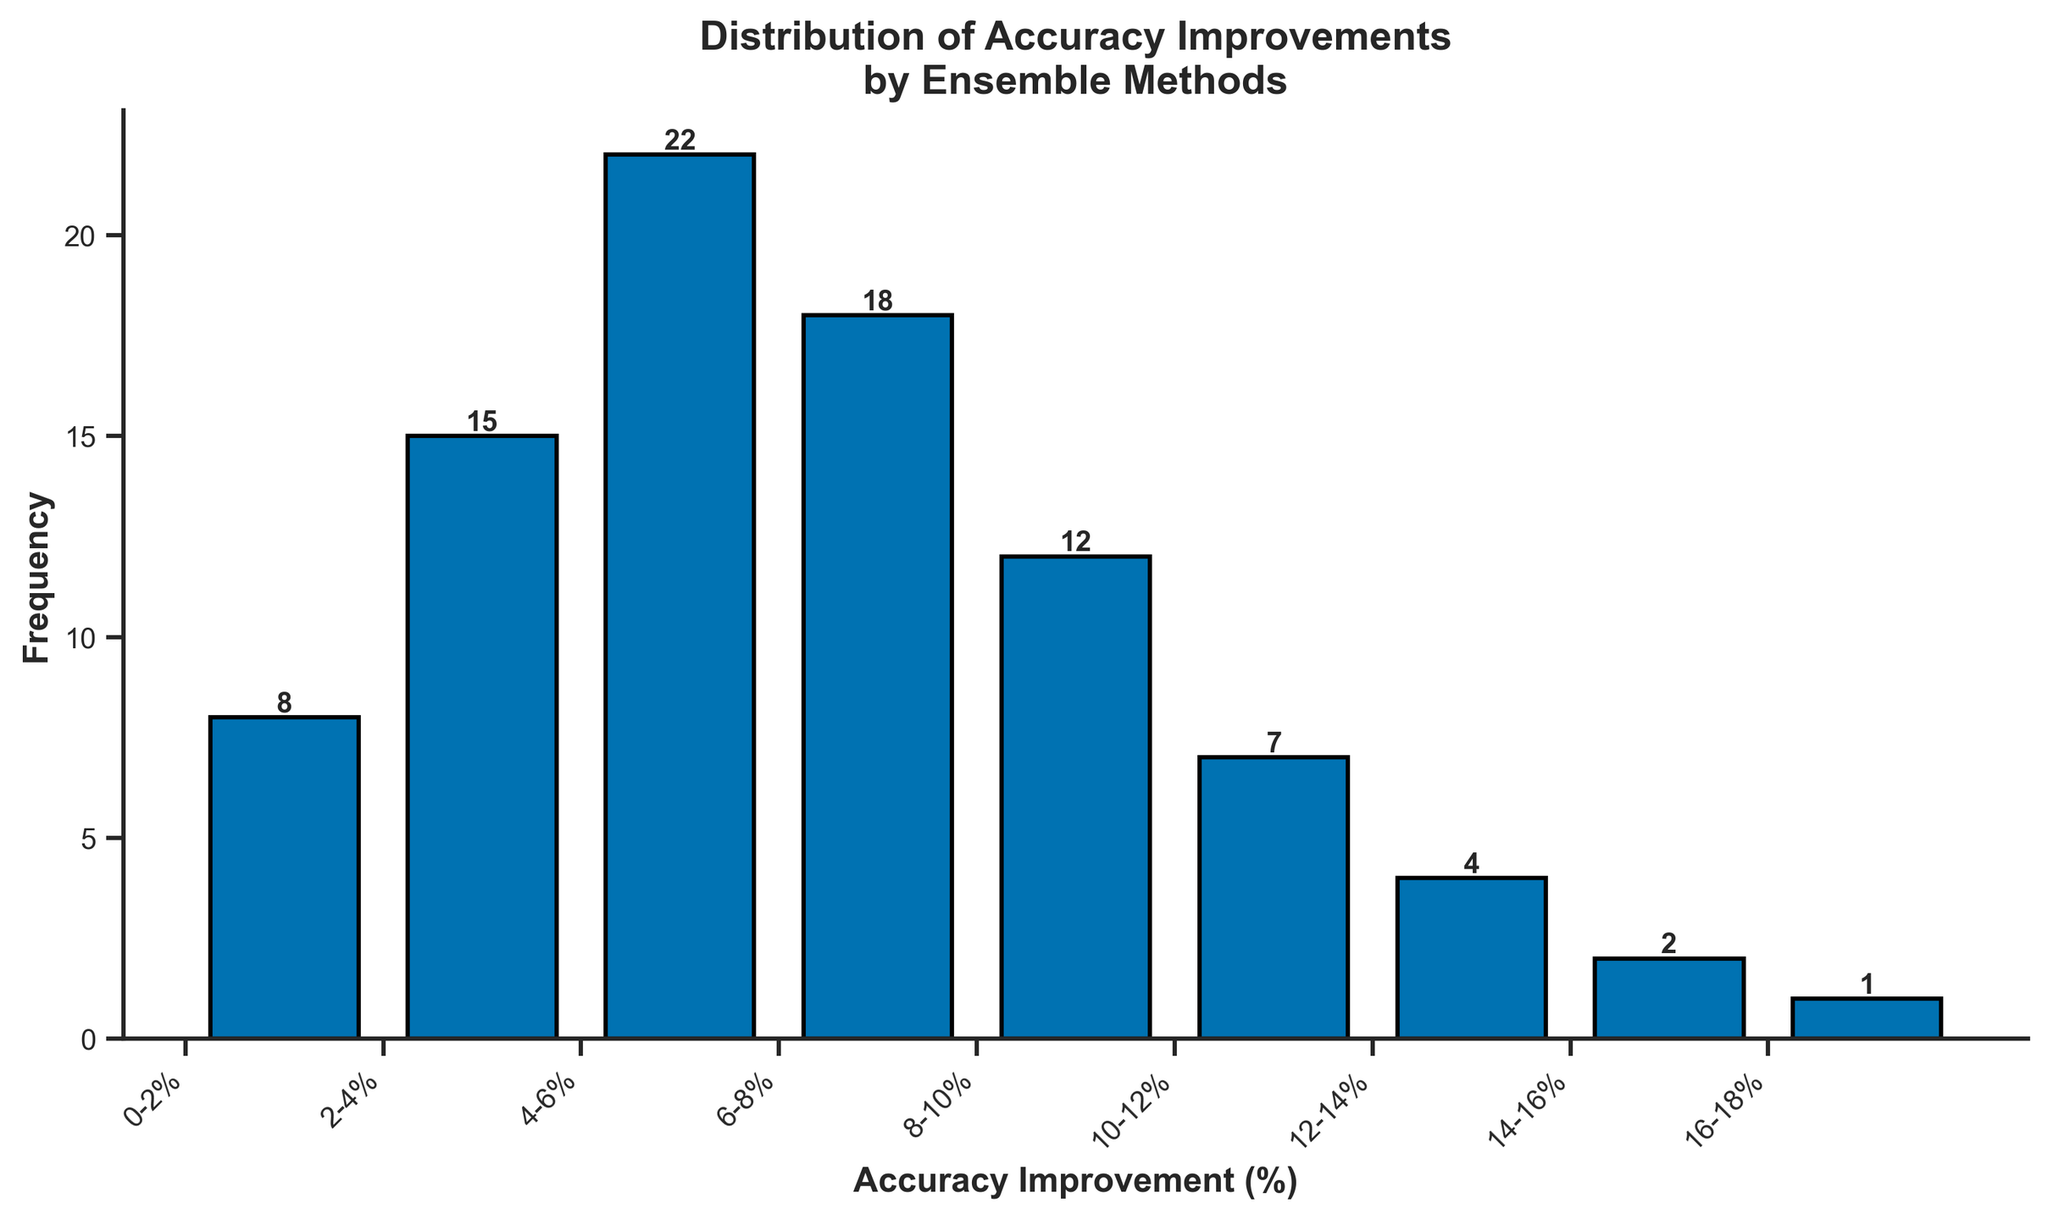What is the highest frequency observed in the histogram? The highest bar in the histogram corresponds to the 4-6% accuracy improvement range, which has a frequency of 22.
Answer: 22 In which range does the least frequency occur? The lowest bar in the histogram corresponds to the 16-18% accuracy improvement range, which has a frequency of 1.
Answer: 16-18% How many accuracy improvement ranges have a frequency greater than 15? The ranges with frequencies greater than 15 are 4-6% and 2-4%.
Answer: 2 Compare the frequency of the 6-8% improvement range to the 8-10% improvement range. The frequency of the 6-8% improvement range is higher than that of the 8-10% improvement range, with values 18 and 12 respectively.
Answer: 18 vs 12 What is the total frequency of all accuracy improvement ranges combined? Adding up the frequencies of all ranges: 8 + 15 + 22 + 18 + 12 + 7 + 4 + 2 + 1 = 89.
Answer: 89 What is the average frequency of the accuracy improvement ranges? The total frequency is 89 spread over 9 ranges. 89 / 9 = 9.89.
Answer: 9.89 How many bars represent a frequency of less than 10? The bars representing frequencies less than 10 are for the ranges: 0-2%, 10-12%, 12-14%, 14-16%, and 16-18%.
Answer: 5 Which accuracy improvement range has the most significant increase in frequency compared to the previous range? Comparing adjacent ranges, the jump from 0-2% (8) to 2-4% (15) shows an increase of 7, and from 2-4% (15) to 4-6% (22) shows an increase of 7. However, relative to their initial values, the jump from 0-2% to 2-4% is a higher percentage increase.
Answer: 2-4% 